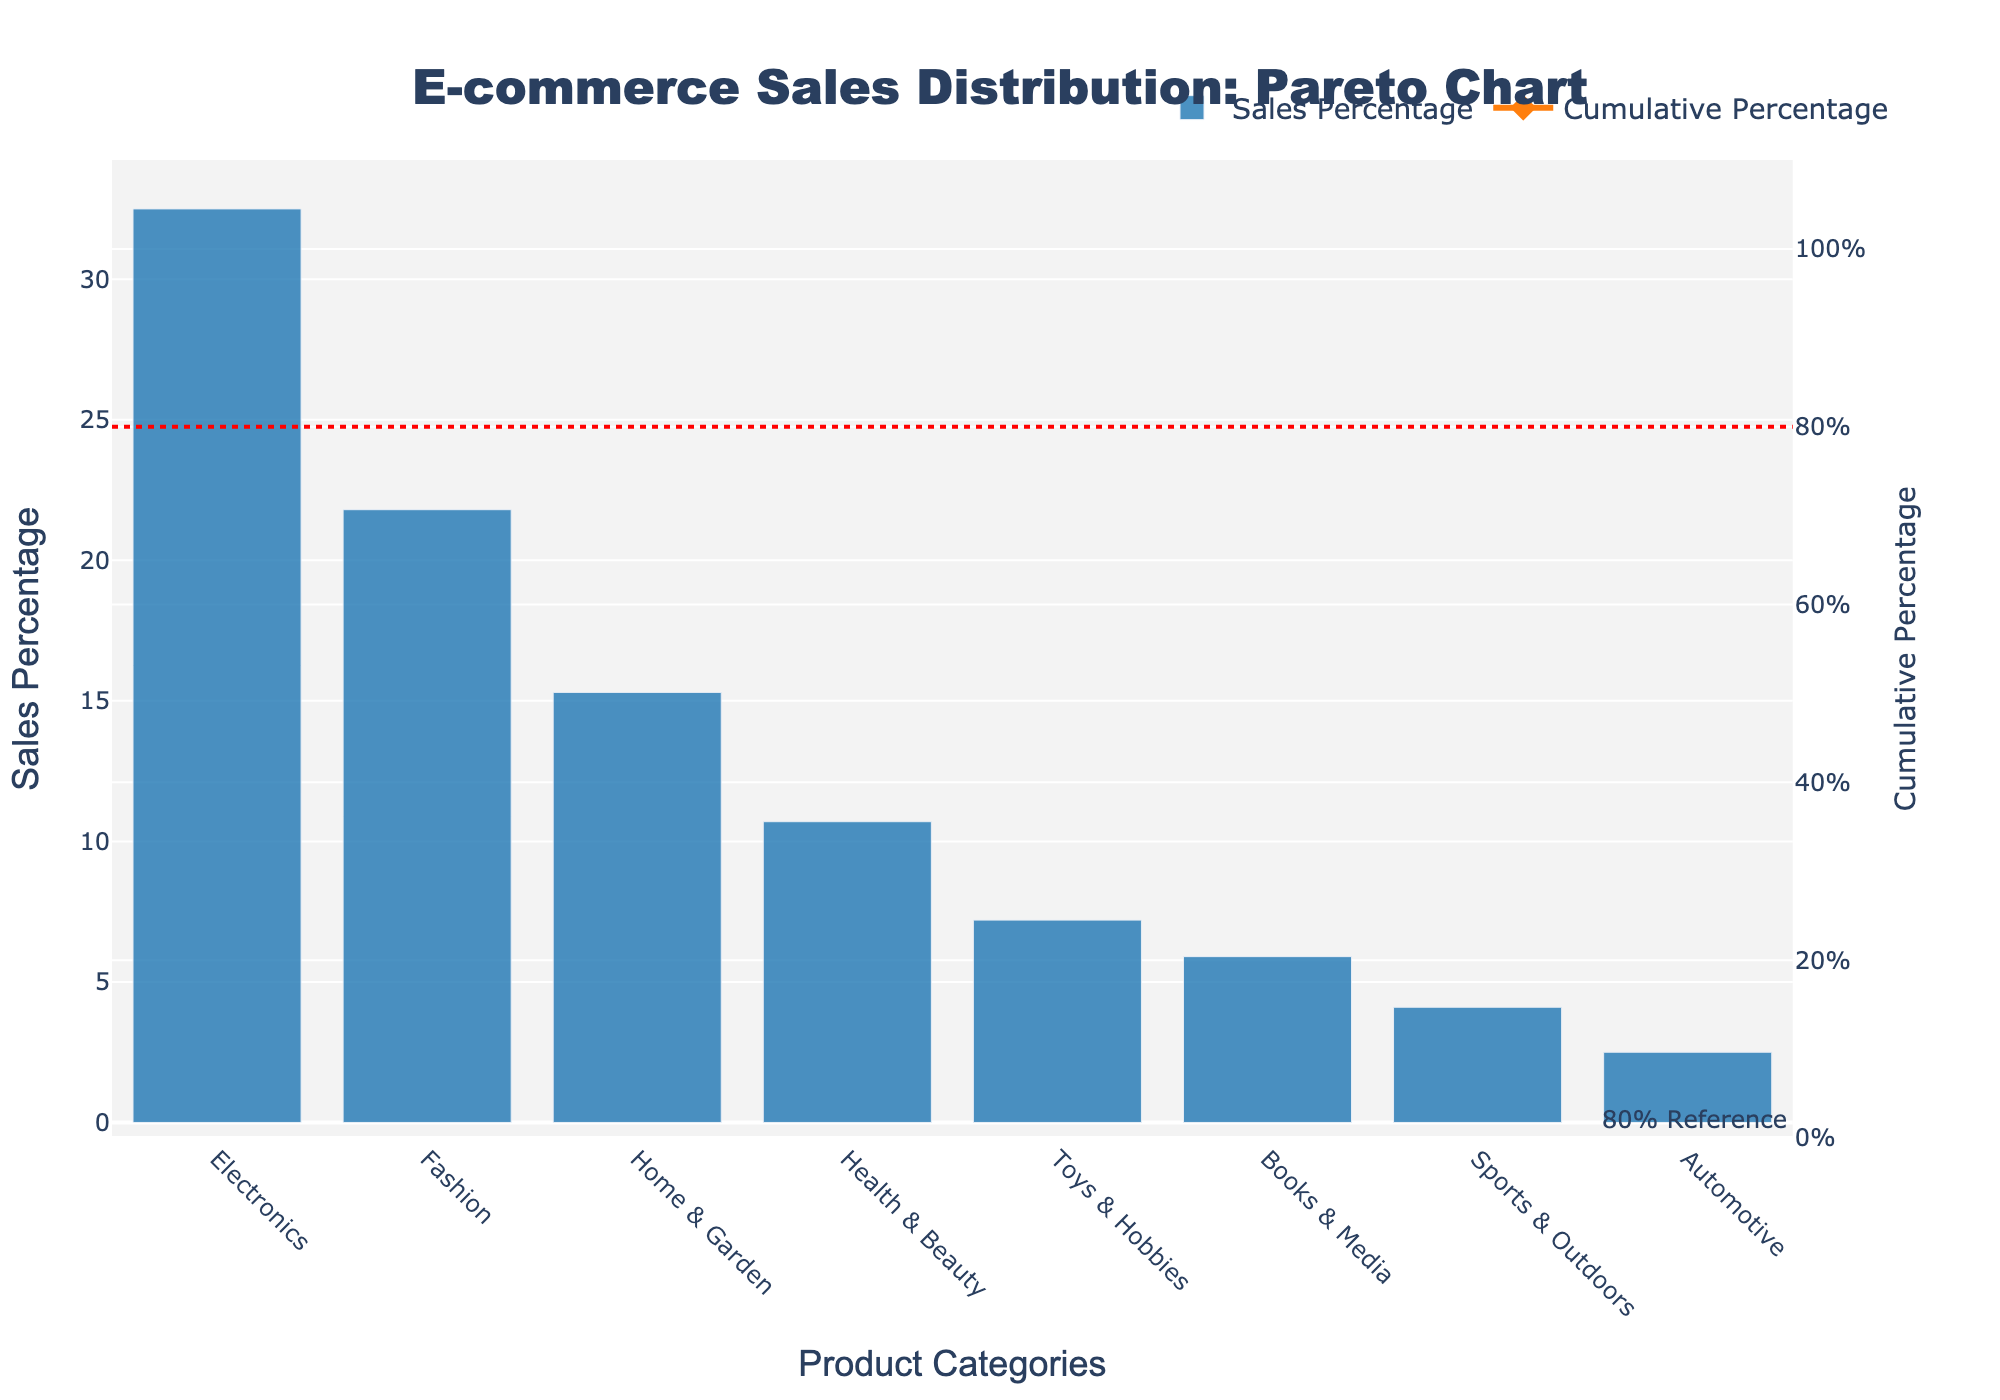What is the title of the figure? The title of the figure is located at the top center of the chart. It reads "E-commerce Sales Distribution: Pareto Chart".
Answer: E-commerce Sales Distribution: Pareto Chart How many product categories are represented in the figure? By counting the labels on the x-axis, we can see there are 8 product categories.
Answer: 8 Which product category has the highest sales percentage? The bar chart shows that the tallest bar corresponds to the "Electronics" category, indicating it has the highest sales percentage.
Answer: Electronics What is the cumulative percentage for the "Fashion" category? The line graph shows cumulative percentages. For "Fashion", which is the second data point, the cumulative percentage is just over 50%.
Answer: About 54.3% What color is used for the bar representing the "Books & Media" category’s sales percentage? The bars representing sales percentages are blue, hence "Books & Media" is also blue.
Answer: Blue How does the sales percentage of "Health & Beauty" compare to "Books & Media"? By comparing the heights of the bars, we see that "Health & Beauty" has a higher sales percentage than "Books & Media".
Answer: "Health & Beauty" is higher What is the approximate cumulative percentage up to the "Home & Garden" category? Sum the sales percentages of "Electronics", "Fashion", and "Home & Garden": 32.5% + 21.8% + 15.3% = 69.6%.
Answer: About 69.6% At which product category does the cumulative percentage reach close to 80%? Looking at the line chart, the cumulative percentage reaches near 80% at the "Health & Beauty" category.
Answer: Health & Beauty What is the significance of the red dashed line? The red dashed line marks the 80% cumulative percentage, which is a reference line commonly used in Pareto analysis to show the threshold for the "vital few" versus the "trivial many".
Answer: 80% threshold Which two product categories have sales percentages under 5%? The bars for "Sports & Outdoors" and "Automotive" are shorter and fall under the 5% mark.
Answer: Sports & Outdoors, Automotive 